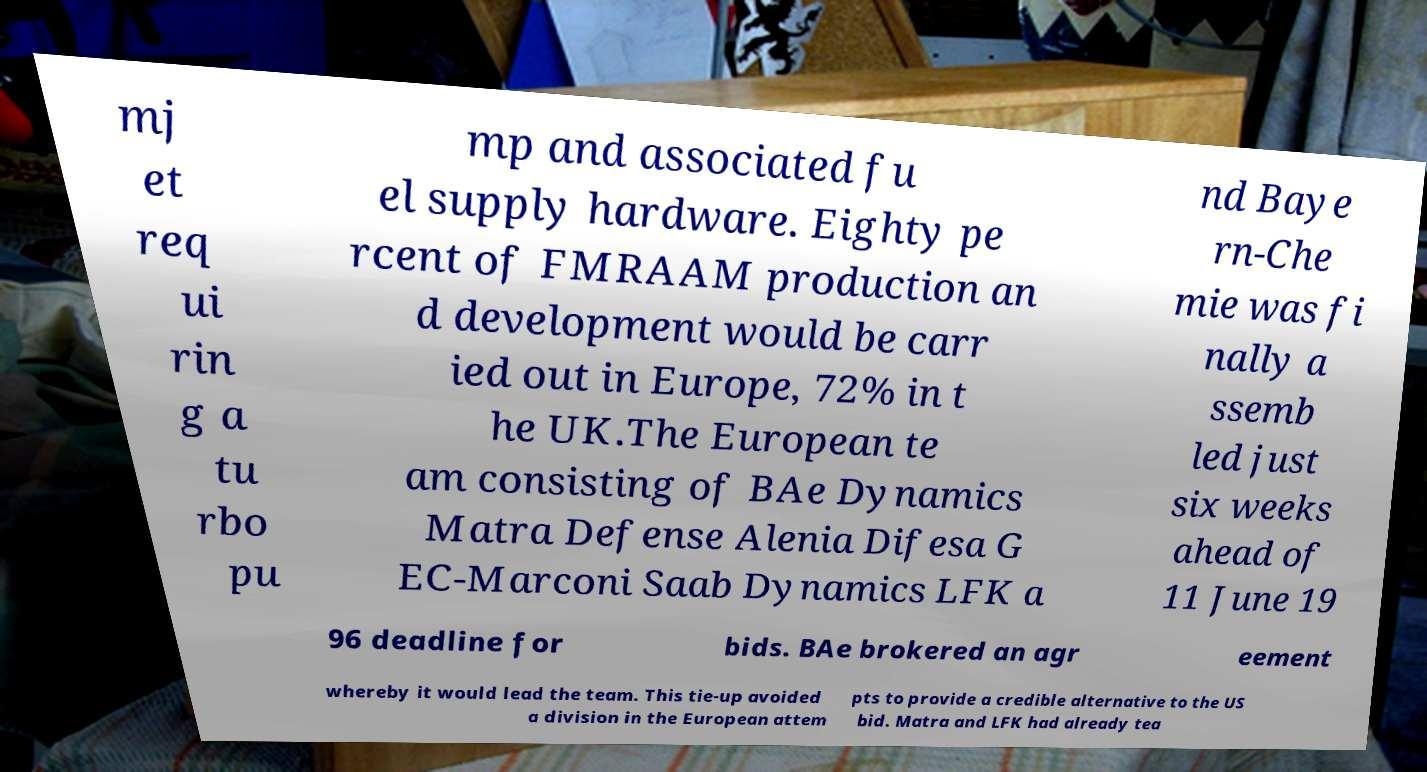What messages or text are displayed in this image? I need them in a readable, typed format. mj et req ui rin g a tu rbo pu mp and associated fu el supply hardware. Eighty pe rcent of FMRAAM production an d development would be carr ied out in Europe, 72% in t he UK.The European te am consisting of BAe Dynamics Matra Defense Alenia Difesa G EC-Marconi Saab Dynamics LFK a nd Baye rn-Che mie was fi nally a ssemb led just six weeks ahead of 11 June 19 96 deadline for bids. BAe brokered an agr eement whereby it would lead the team. This tie-up avoided a division in the European attem pts to provide a credible alternative to the US bid. Matra and LFK had already tea 